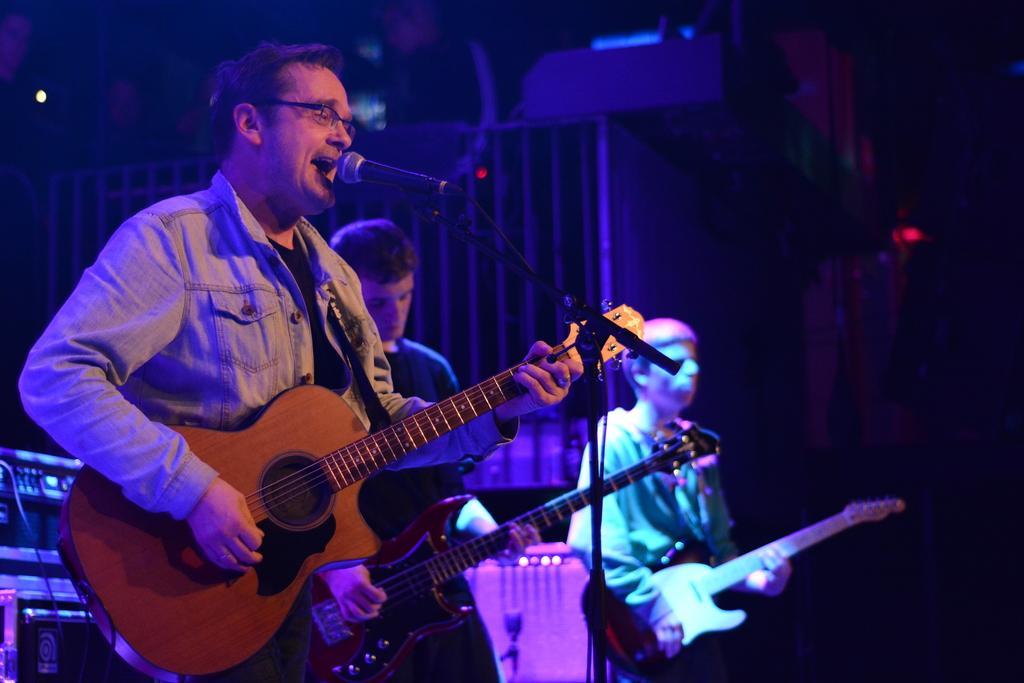In one or two sentences, can you explain what this image depicts? In this picture we can see three men standing in front of a mike singing and playing guitars and the background is very dark. 